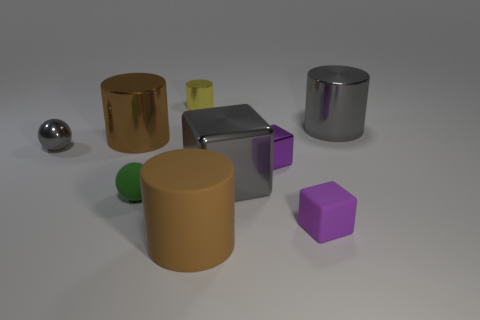How many objects have a metallic sheen? There are two objects with a metallic finish, one is a silver sphere, and the other is a cylinder with a silvery-chrome finish. 